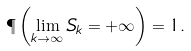<formula> <loc_0><loc_0><loc_500><loc_500>\P \left ( \lim _ { k \to \infty } { S _ { k } } = + \infty \right ) = 1 .</formula> 